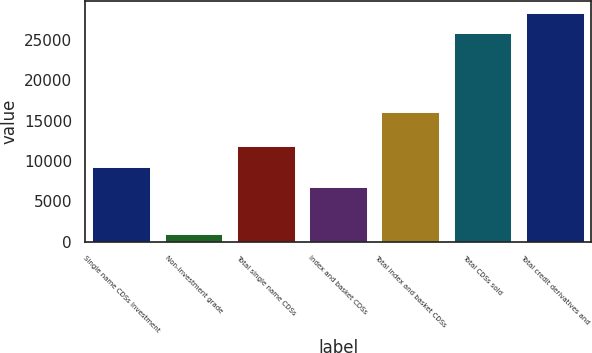Convert chart to OTSL. <chart><loc_0><loc_0><loc_500><loc_500><bar_chart><fcel>Single name CDSs Investment<fcel>Non-investment grade<fcel>Total single name CDSs<fcel>Index and basket CDSs<fcel>Total index and basket CDSs<fcel>Total CDSs sold<fcel>Total credit derivatives and<nl><fcel>9317.2<fcel>908<fcel>11827.4<fcel>6807<fcel>16096<fcel>25876<fcel>28386.2<nl></chart> 